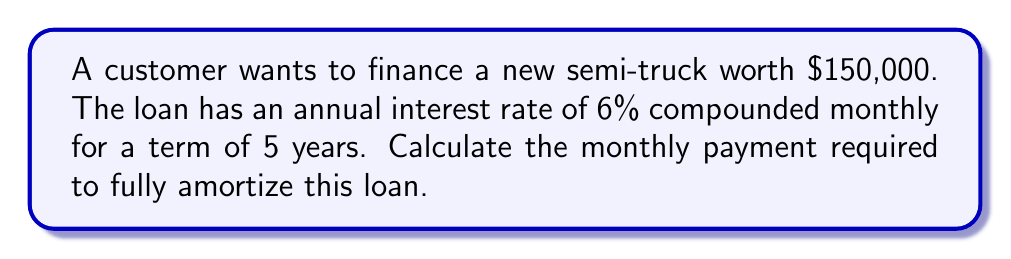Give your solution to this math problem. To calculate the monthly payment, we'll use the compound interest formula for loan payments:

$$P = L \cdot \frac{r(1+r)^n}{(1+r)^n - 1}$$

Where:
$P$ = monthly payment
$L$ = loan amount
$r$ = monthly interest rate
$n$ = total number of monthly payments

Step 1: Determine the values
$L = 150,000$
Annual rate = 6% = 0.06
$r = 0.06 / 12 = 0.005$ (monthly rate)
$n = 5 \cdot 12 = 60$ months

Step 2: Plug the values into the formula
$$P = 150,000 \cdot \frac{0.005(1+0.005)^{60}}{(1+0.005)^{60} - 1}$$

Step 3: Calculate
$$P = 150,000 \cdot \frac{0.005(1.3489)}{0.3489}$$
$$P = 150,000 \cdot 0.0193$$
$$P = 2,895.45$$

Therefore, the monthly payment is $2,895.45.
Answer: $2,895.45 